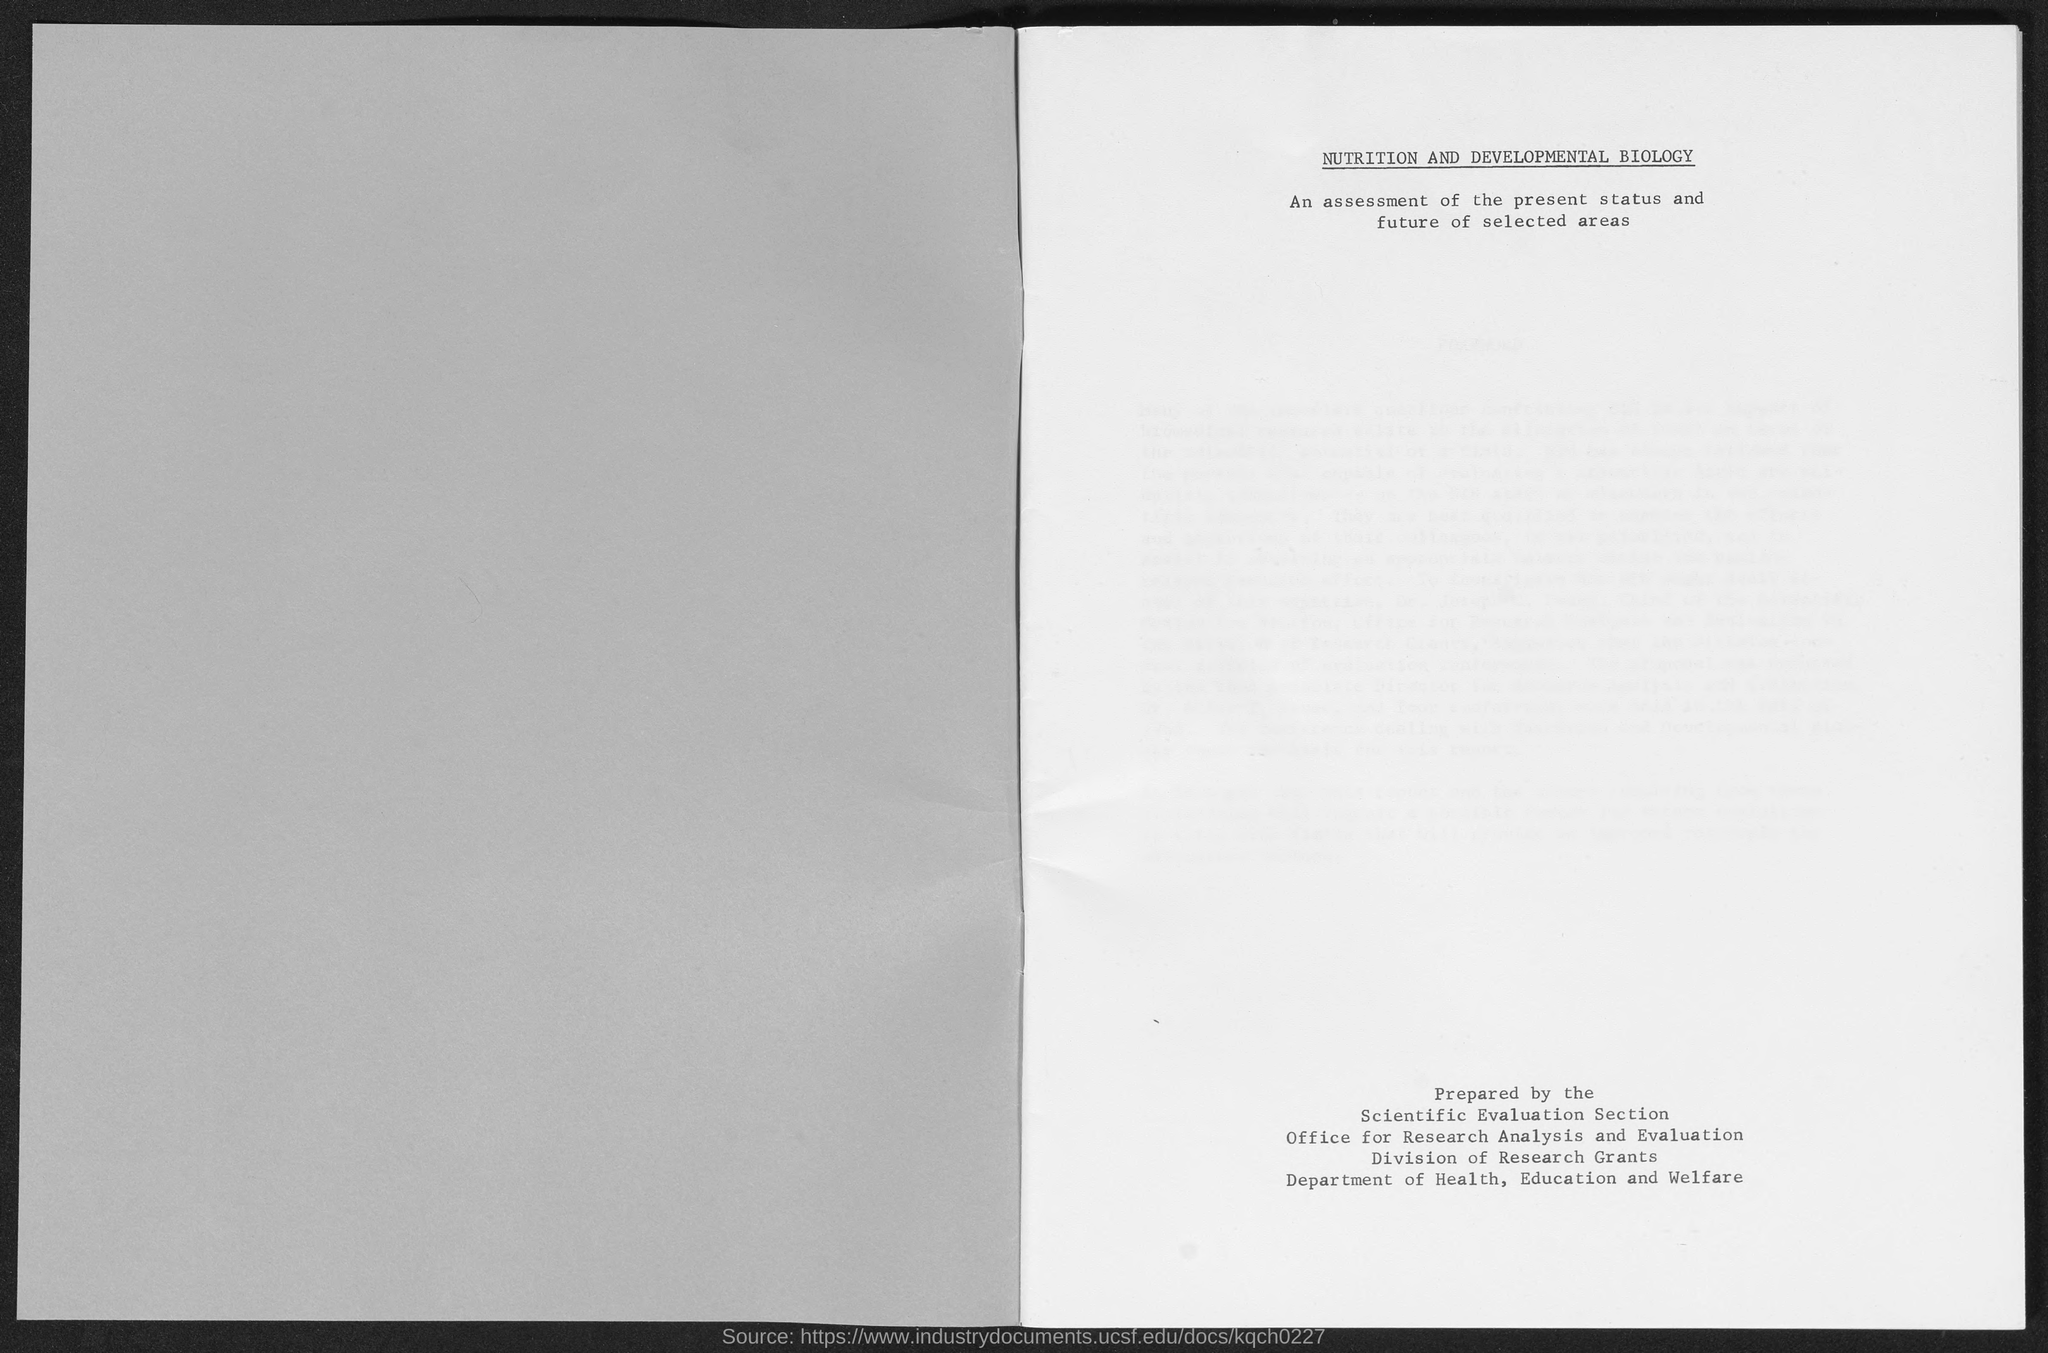What is the title of the document?
Ensure brevity in your answer.  NUTRITION AND DEVELOPMENTAL BIOLOGY. 